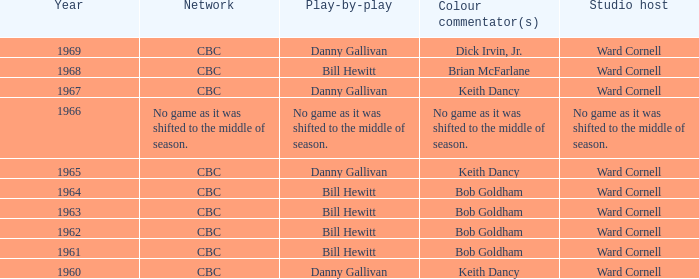Were bill hewitt's color commentator colleagues involved in the play-by-play broadcasting? Brian McFarlane, Bob Goldham, Bob Goldham, Bob Goldham, Bob Goldham. 